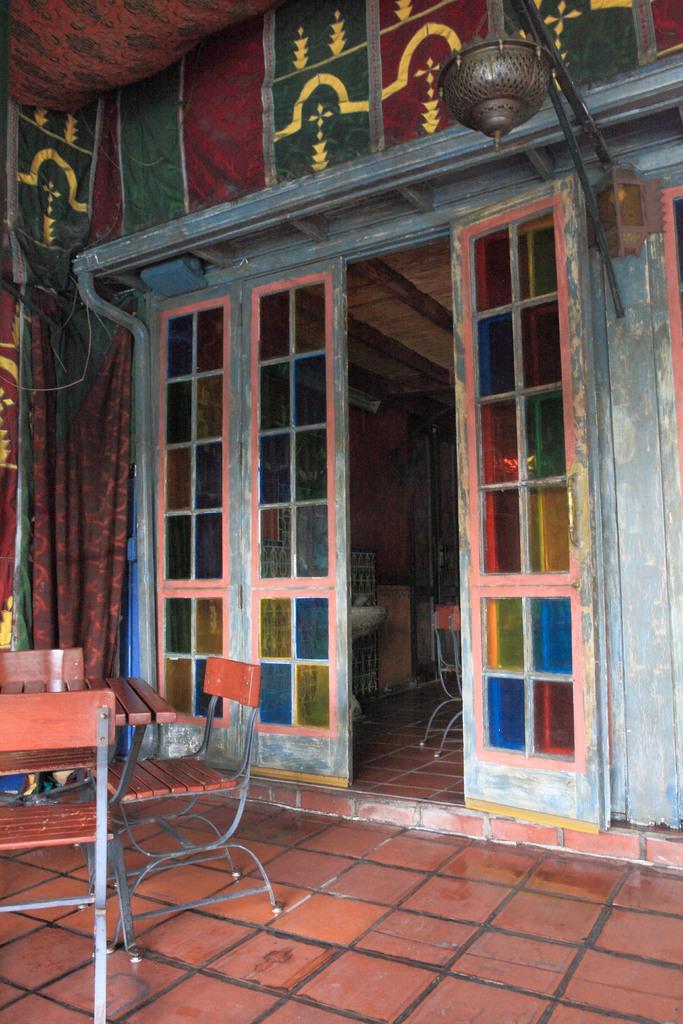Can you describe this image briefly? In this image there is a table and chairs on the floor, behind that there is a door of a building and there is an object hanging on the wall and on the other side there are curtains. 